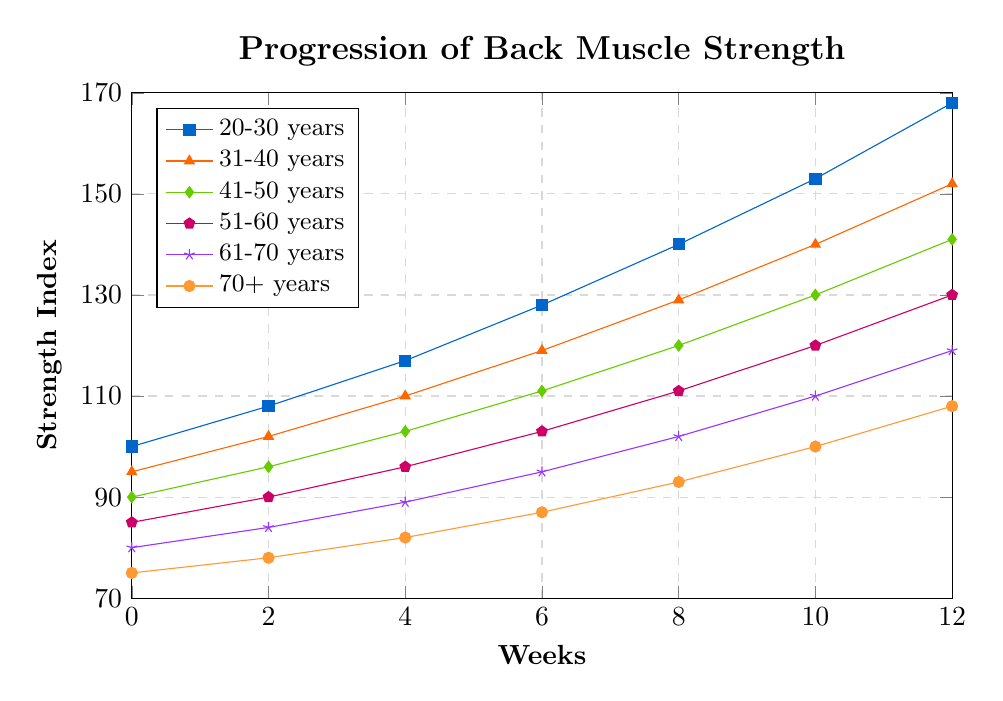What's the range of the strength index for the 20-30 years age group at Week 12? The highest value for the 20-30 years age group is 168, and the lowest value at Week 12 for any group is 108 (70+ years). So the range is 168 - 108 = 60.
Answer: 60 Which age group showed the greatest increase in back muscle strength from Week 0 to Week 12? To find the greatest increase, we subtract the Week 0 value from the Week 12 value for each group. The increases are: 20-30 years (168-100=68), 31-40 years (152-95=57), 41-50 years (141-90=51), 51-60 years (130-85=45), 61-70 years (119-80=39), 70+ years (108-75=33). The greatest increase is 20-30 years with 68.
Answer: 20-30 years How does the strength index of the 31-40 years age group at Week 6 compare to the 61-70 years age group at Week 10? The strength index for 31-40 years at Week 6 is 119, and for 61-70 years at Week 10 it is 110. Thus, 119 is greater than 110.
Answer: 119 > 110 What's the average strength index for the 51-60 years age group over the 12 weeks? The values for the 51-60 years group are 85, 90, 96, 103, 111, 120, 130. The sum is (85 + 90 + 96 + 103 + 111 + 120 + 130 = 735). There are 7 values, so the average is 735 / 7 = 105.
Answer: 105 Which age group had the lowest back muscle strength increase from Week 8 to Week 12? The increases from Week 8 to Week 12 are: 20-30 years (168-140=28), 31-40 years (152-129=23), 41-50 years (141-120=21), 51-60 years (130-111=19), 61-70 years (119-102=17), 70+ years (108-93=15). The lowest increase is 70+ years with 15.
Answer: 70+ years What color represents the 41-50 years age group in the plot? The plot uses specific colors for each age group. According to the provided data, the 41-50 years age group is represented by a diamond mark which is matched to a green color.
Answer: Green By how much did the strength index of the 20-30 years group rise from Week 4 to Week 10? The strength index for the 20-30 years group is 117 at Week 4 and 153 at Week 10. The increase is 153 - 117 = 36.
Answer: 36 